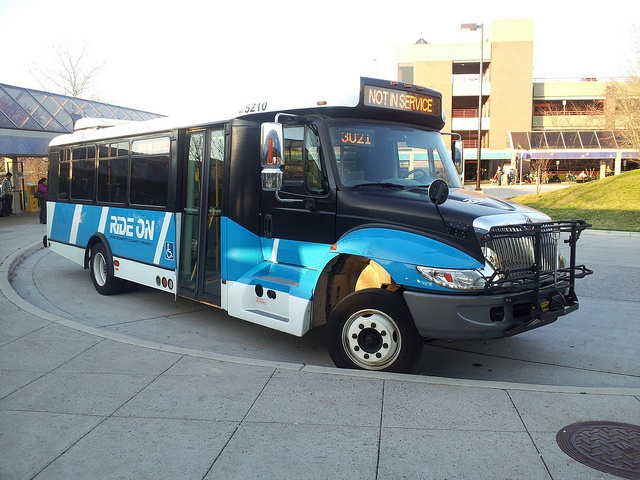Describe the objects in this image and their specific colors. I can see bus in white, black, gray, lightgray, and teal tones, people in white, black, gray, darkgray, and maroon tones, people in white, black, purple, and gray tones, people in white, tan, gray, khaki, and maroon tones, and people in white, gray, tan, darkgray, and beige tones in this image. 